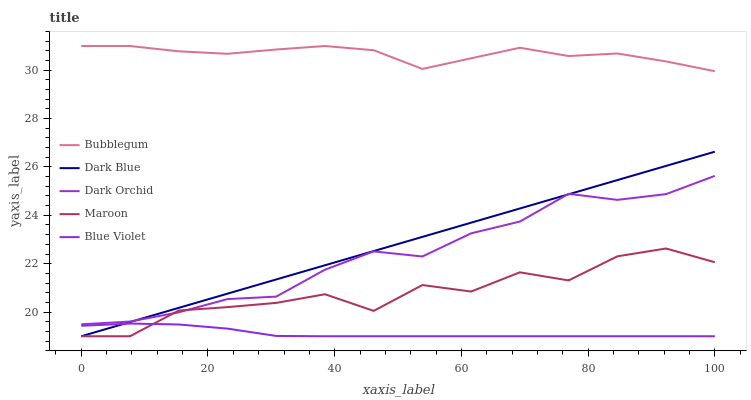Does Blue Violet have the minimum area under the curve?
Answer yes or no. Yes. Does Bubblegum have the maximum area under the curve?
Answer yes or no. Yes. Does Dark Blue have the minimum area under the curve?
Answer yes or no. No. Does Dark Blue have the maximum area under the curve?
Answer yes or no. No. Is Dark Blue the smoothest?
Answer yes or no. Yes. Is Maroon the roughest?
Answer yes or no. Yes. Is Blue Violet the smoothest?
Answer yes or no. No. Is Blue Violet the roughest?
Answer yes or no. No. Does Dark Orchid have the lowest value?
Answer yes or no. No. Does Dark Blue have the highest value?
Answer yes or no. No. Is Blue Violet less than Bubblegum?
Answer yes or no. Yes. Is Bubblegum greater than Dark Blue?
Answer yes or no. Yes. Does Blue Violet intersect Bubblegum?
Answer yes or no. No. 